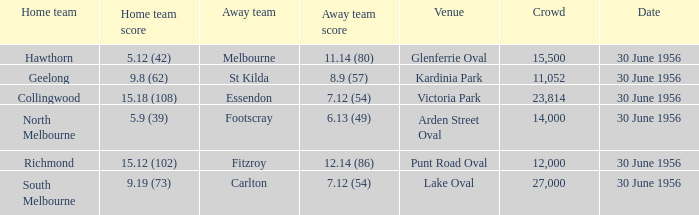18 (108)? Essendon. 